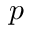<formula> <loc_0><loc_0><loc_500><loc_500>p</formula> 